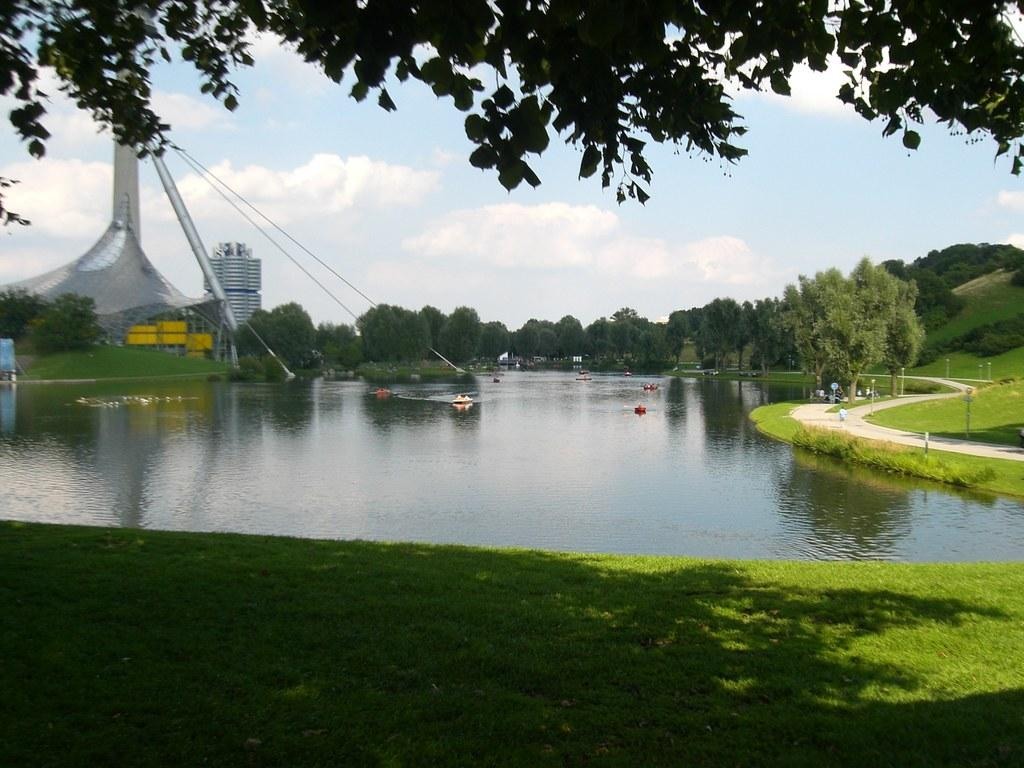What type of natural body of water is present in the image? There is a lake in the image. What type of pathway can be seen in the image? There is a walkway in the image. What type of vegetation is present in the image? There is grass in the image. What type of plants are present in the image? There are trees in the image. Where are the buildings located in the image? There are two buildings on the left side of the image. What is the condition of the sky in the image? The sky is clear in the image. What type of bean is being selected by the person in the image? There is no person or bean present in the image. 